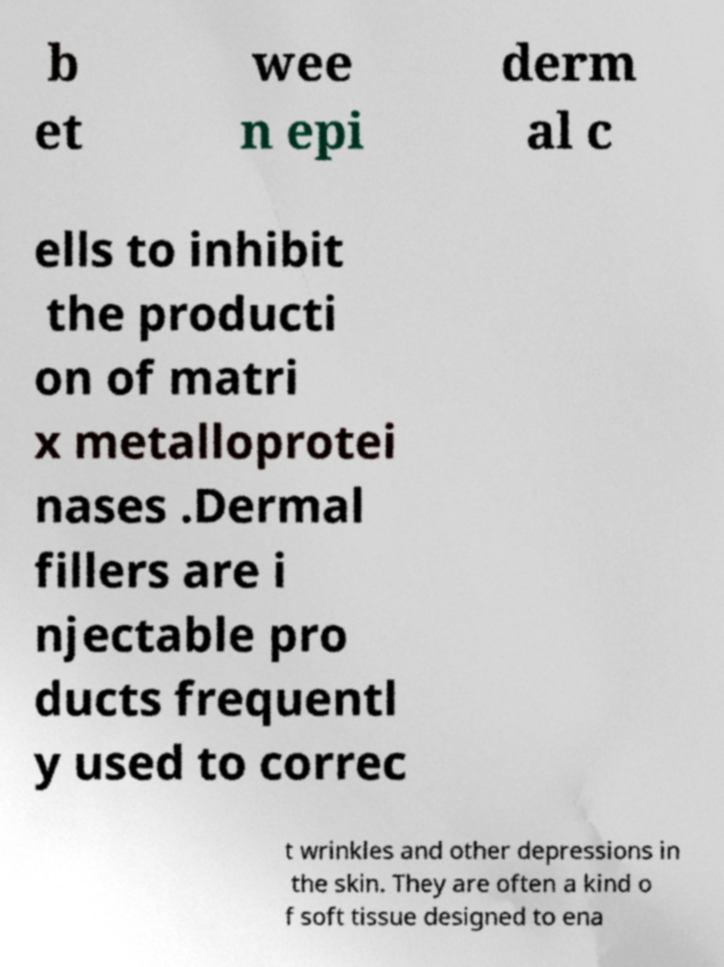Please identify and transcribe the text found in this image. b et wee n epi derm al c ells to inhibit the producti on of matri x metalloprotei nases .Dermal fillers are i njectable pro ducts frequentl y used to correc t wrinkles and other depressions in the skin. They are often a kind o f soft tissue designed to ena 